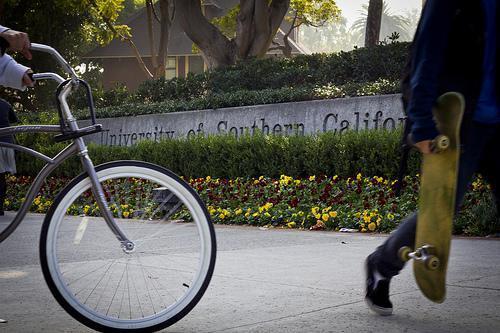How many people are in the picture?
Give a very brief answer. 2. 